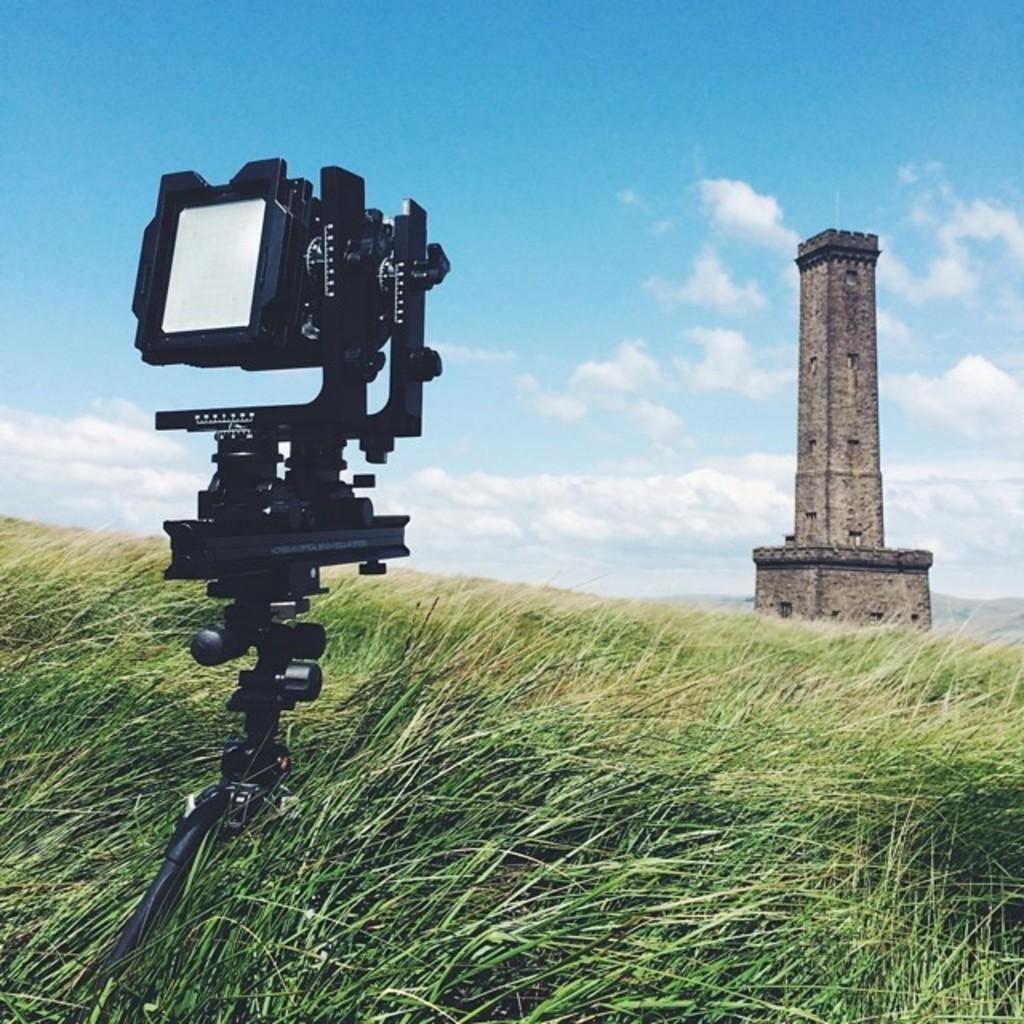In one or two sentences, can you explain what this image depicts? In this image I can see a camera,green grass and a tower. The sky is in white and blue color. 